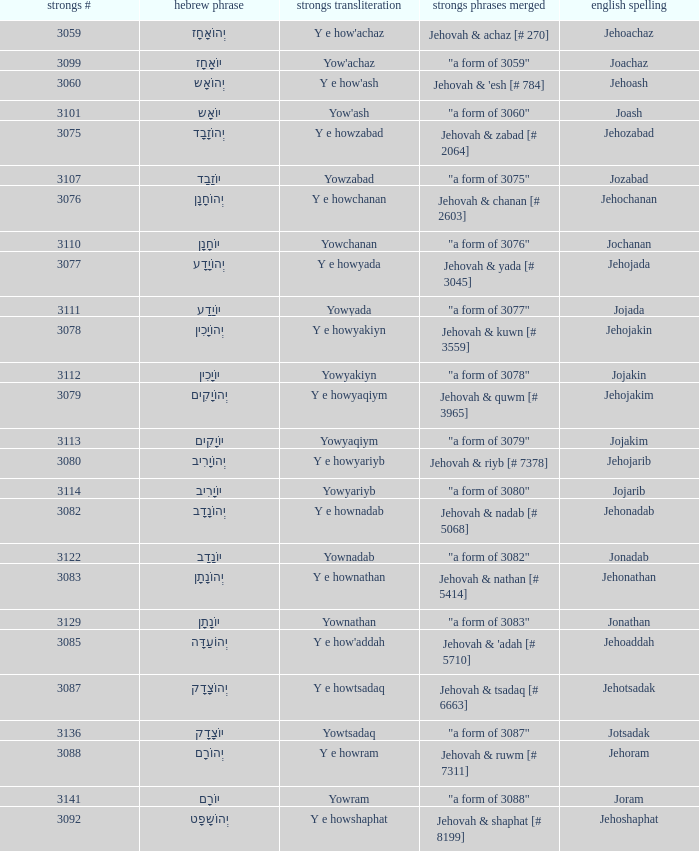What is the strong words compounded when the strongs transliteration is yowyariyb? "a form of 3080". 